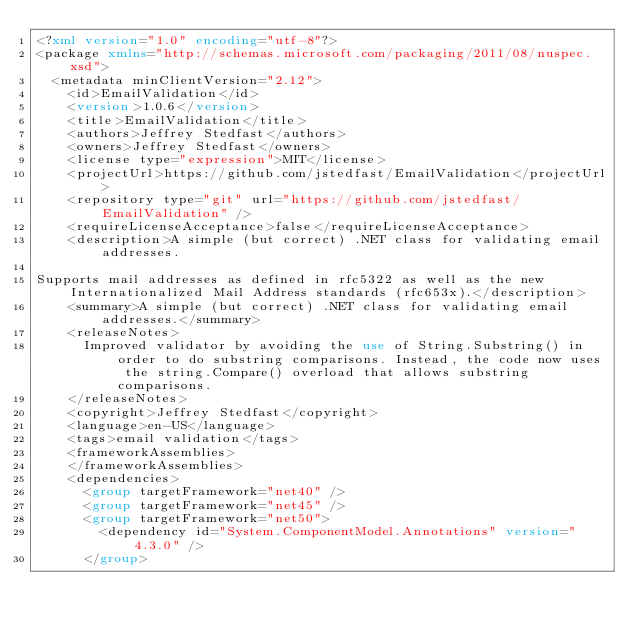<code> <loc_0><loc_0><loc_500><loc_500><_XML_><?xml version="1.0" encoding="utf-8"?>
<package xmlns="http://schemas.microsoft.com/packaging/2011/08/nuspec.xsd">
  <metadata minClientVersion="2.12">
    <id>EmailValidation</id>
    <version>1.0.6</version>
    <title>EmailValidation</title>
    <authors>Jeffrey Stedfast</authors>
    <owners>Jeffrey Stedfast</owners>
    <license type="expression">MIT</license>
    <projectUrl>https://github.com/jstedfast/EmailValidation</projectUrl>
    <repository type="git" url="https://github.com/jstedfast/EmailValidation" />
    <requireLicenseAcceptance>false</requireLicenseAcceptance>
    <description>A simple (but correct) .NET class for validating email addresses.

Supports mail addresses as defined in rfc5322 as well as the new Internationalized Mail Address standards (rfc653x).</description>
    <summary>A simple (but correct) .NET class for validating email addresses.</summary>
    <releaseNotes>
      Improved validator by avoiding the use of String.Substring() in order to do substring comparisons. Instead, the code now uses the string.Compare() overload that allows substring comparisons.
    </releaseNotes>
    <copyright>Jeffrey Stedfast</copyright>
    <language>en-US</language>
    <tags>email validation</tags>
    <frameworkAssemblies>
    </frameworkAssemblies>
    <dependencies>
      <group targetFramework="net40" />
      <group targetFramework="net45" />
      <group targetFramework="net50">
        <dependency id="System.ComponentModel.Annotations" version="4.3.0" />
      </group></code> 